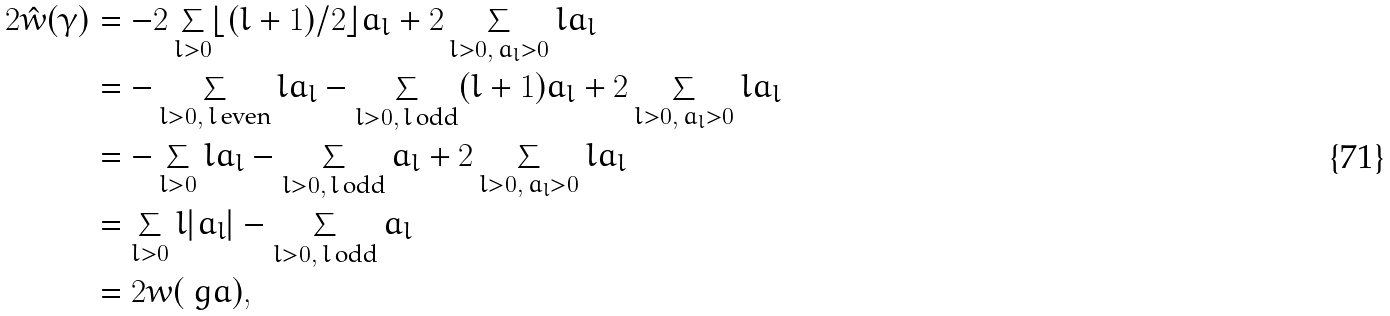<formula> <loc_0><loc_0><loc_500><loc_500>2 \hat { w } ( \gamma ) & = - 2 \sum _ { l > 0 } \lfloor ( l + 1 ) / 2 \rfloor a _ { l } + 2 \sum _ { l > 0 , \, a _ { l } > 0 } l a _ { l } \\ & = - \sum _ { l > 0 , \, l \, \text {even} } l a _ { l } - \sum _ { l > 0 , \, l \, \text {odd} } ( l + 1 ) a _ { l } + 2 \sum _ { l > 0 , \, a _ { l } > 0 } l a _ { l } \\ & = - \sum _ { l > 0 } l a _ { l } - \sum _ { l > 0 , \, l \, \text {odd} } a _ { l } + 2 \sum _ { l > 0 , \, a _ { l } > 0 } l a _ { l } \\ & = \sum _ { l > 0 } l | a _ { l } | - \sum _ { l > 0 , \, l \, \text {odd} } a _ { l } \\ & = 2 w ( \ g a ) ,</formula> 